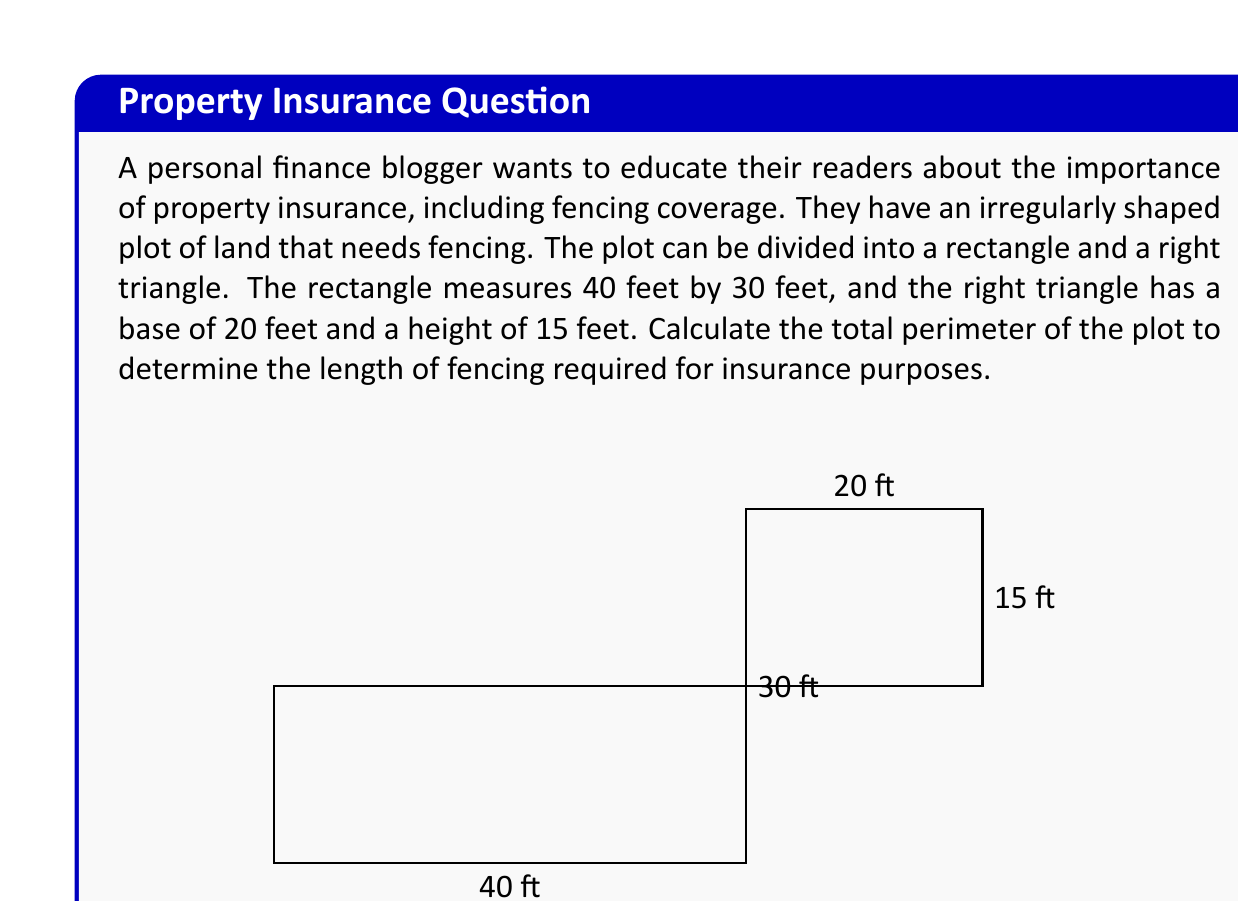Provide a solution to this math problem. To solve this problem, we need to calculate the perimeter of the entire plot by adding up the lengths of all sides. Let's break it down step by step:

1. Identify the known dimensions:
   - Rectangle: 40 ft × 30 ft
   - Right triangle: base = 20 ft, height = 15 ft

2. Calculate the perimeter of the rectangle:
   $$P_{rectangle} = 2(l + w) = 2(40 + 30) = 2(70) = 140 \text{ ft}$$

3. For the right triangle, we need to calculate the hypotenuse using the Pythagorean theorem:
   $$c^2 = a^2 + b^2$$
   $$c^2 = 20^2 + 15^2 = 400 + 225 = 625$$
   $$c = \sqrt{625} = 25 \text{ ft}$$

4. Now, we can calculate the perimeter of the entire plot:
   - Start with the rectangle's perimeter: 140 ft
   - Subtract the side shared by the rectangle and triangle: -30 ft
   - Add the hypotenuse and base of the triangle: +25 ft + 20 ft

5. Total perimeter:
   $$P_{total} = 140 - 30 + 25 + 20 = 155 \text{ ft}$$

Therefore, the total perimeter of the irregularly shaped plot is 155 feet, which is the length of fencing required for insurance purposes.
Answer: 155 ft 